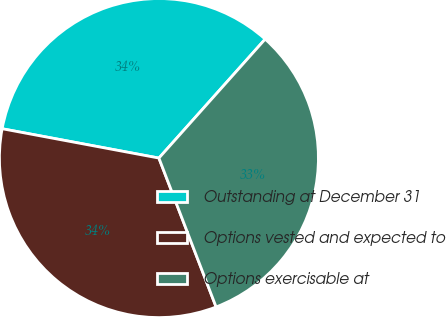<chart> <loc_0><loc_0><loc_500><loc_500><pie_chart><fcel>Outstanding at December 31<fcel>Options vested and expected to<fcel>Options exercisable at<nl><fcel>33.66%<fcel>33.78%<fcel>32.56%<nl></chart> 